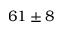Convert formula to latex. <formula><loc_0><loc_0><loc_500><loc_500>6 1 \pm 8</formula> 